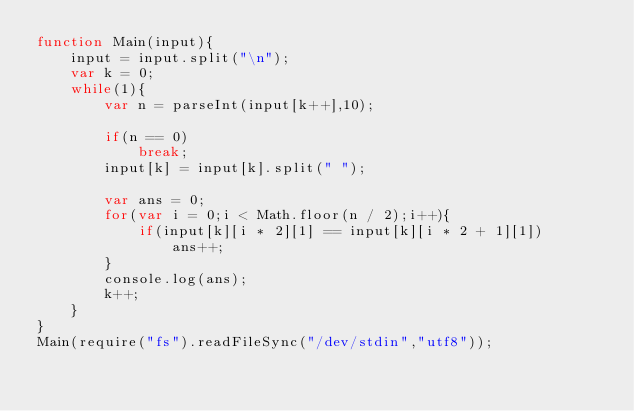<code> <loc_0><loc_0><loc_500><loc_500><_JavaScript_>function Main(input){
    input = input.split("\n");
    var k = 0;
    while(1){
        var n = parseInt(input[k++],10);

        if(n == 0)
            break;
        input[k] = input[k].split(" ");

        var ans = 0;
        for(var i = 0;i < Math.floor(n / 2);i++){
            if(input[k][i * 2][1] == input[k][i * 2 + 1][1])
                ans++;
        }
        console.log(ans);
        k++;
    }
}
Main(require("fs").readFileSync("/dev/stdin","utf8"));</code> 